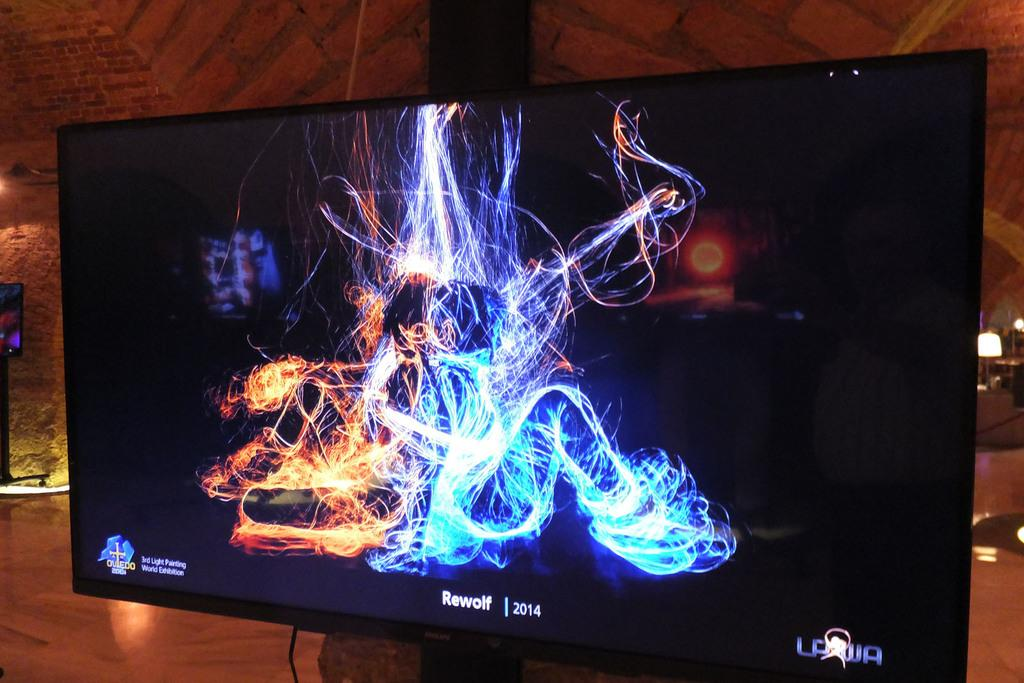<image>
Relay a brief, clear account of the picture shown. A large size tv screen mounted on a post with the brand name Rewolf at the bottom of the screen. 